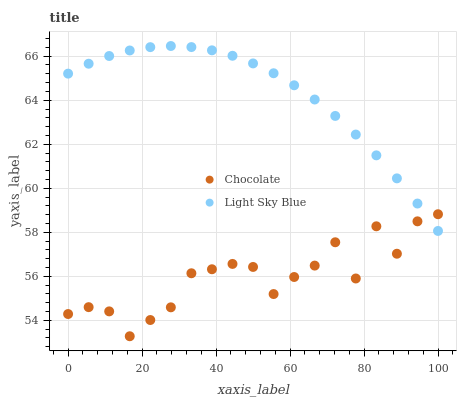Does Chocolate have the minimum area under the curve?
Answer yes or no. Yes. Does Light Sky Blue have the maximum area under the curve?
Answer yes or no. Yes. Does Chocolate have the maximum area under the curve?
Answer yes or no. No. Is Light Sky Blue the smoothest?
Answer yes or no. Yes. Is Chocolate the roughest?
Answer yes or no. Yes. Is Chocolate the smoothest?
Answer yes or no. No. Does Chocolate have the lowest value?
Answer yes or no. Yes. Does Light Sky Blue have the highest value?
Answer yes or no. Yes. Does Chocolate have the highest value?
Answer yes or no. No. Does Chocolate intersect Light Sky Blue?
Answer yes or no. Yes. Is Chocolate less than Light Sky Blue?
Answer yes or no. No. Is Chocolate greater than Light Sky Blue?
Answer yes or no. No. 